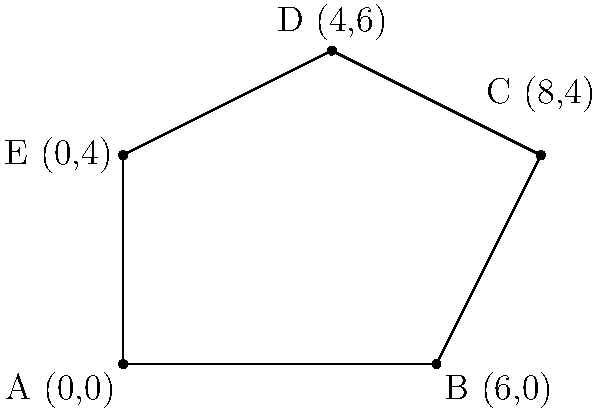A telemedicine service zone in rural Cambodia is represented by the polygonal region ABCDE shown in the coordinate plane. Each unit represents 1 km. Calculate the area of this service zone in square kilometers. To find the area of the polygonal region, we can use the Shoelace formula (also known as the surveyor's formula). The steps are as follows:

1) First, list the coordinates of the vertices in order:
   A(0,0), B(6,0), C(8,4), D(4,6), E(0,4)

2) Apply the Shoelace formula:
   Area = $\frac{1}{2}|(x_1y_2 + x_2y_3 + ... + x_ny_1) - (y_1x_2 + y_2x_3 + ... + y_nx_1)|$

3) Substitute the values:
   Area = $\frac{1}{2}|[(0 \cdot 0) + (6 \cdot 4) + (8 \cdot 6) + (4 \cdot 4) + (0 \cdot 0)] - [(0 \cdot 6) + (0 \cdot 8) + (4 \cdot 4) + (6 \cdot 0) + (4 \cdot 0)]|$

4) Simplify:
   Area = $\frac{1}{2}|(0 + 24 + 48 + 16 + 0) - (0 + 0 + 16 + 0 + 0)|$
   Area = $\frac{1}{2}|88 - 16|$
   Area = $\frac{1}{2} \cdot 72$
   Area = 36

Therefore, the area of the service zone is 36 square kilometers.
Answer: 36 km² 